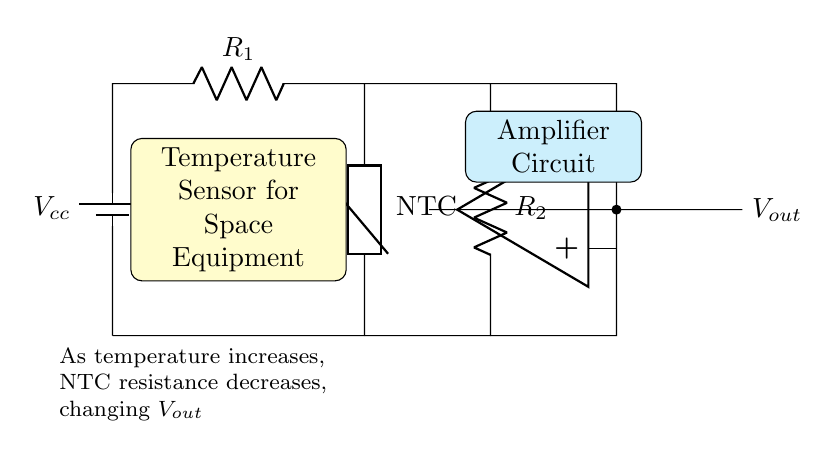What type of thermistor is used in this circuit? The circuit diagram identifies the thermistor as an NTC (Negative Temperature Coefficient) type, which indicates that its resistance decreases with increasing temperature.
Answer: NTC What does the output voltage depend on? The output voltage is a function of the temperature sensed by the thermistor and the corresponding changes in resistance, impacting the voltage divider formed by the resistors and the thermistor.
Answer: Temperature How many resistors are present in the circuit? The circuit includes two resistors, one is labeled as R1 and the other as R2, connected in specific parts of the circuit to form a voltage divider with the thermistor.
Answer: two What is the purpose of the op-amp in this circuit? The operational amplifier amplifies the output voltage signal from the divider circuit formed by the thermistor and resistors, which allows for better monitoring and readings on space equipment.
Answer: Amplification What happens to the output voltage as temperature increases? As temperature rises, the resistance of the NTC thermistor decreases, leading to a decrease in the voltage across it, which subsequently affects the output voltage, resulting in a predictable circuit response.
Answer: Decreases 